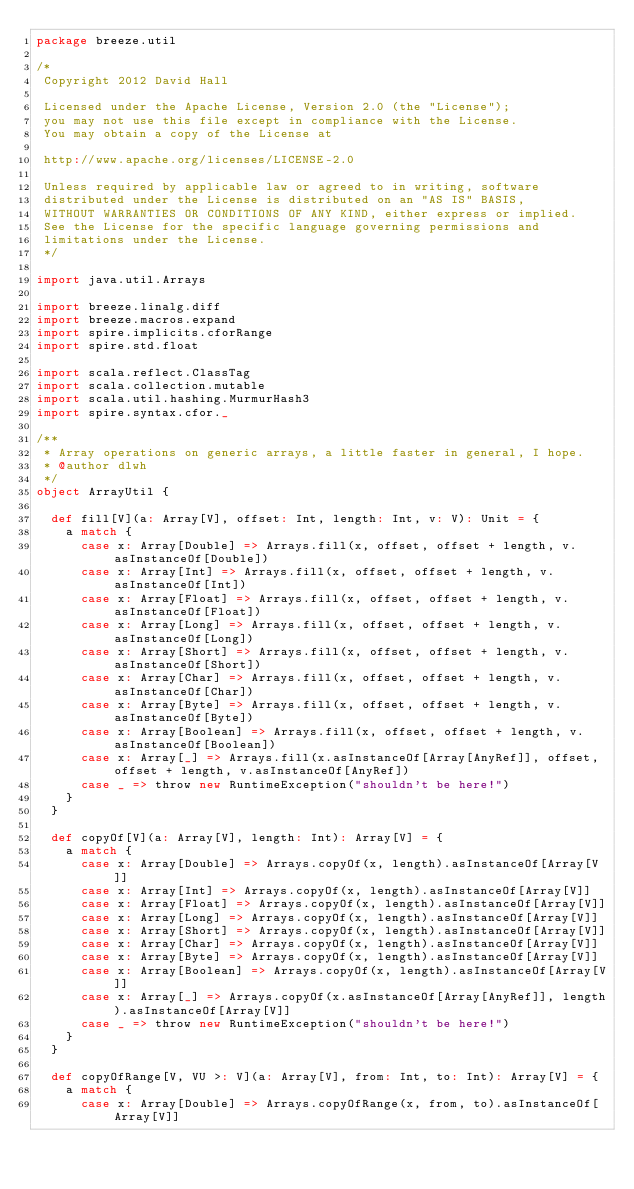<code> <loc_0><loc_0><loc_500><loc_500><_Scala_>package breeze.util

/*
 Copyright 2012 David Hall

 Licensed under the Apache License, Version 2.0 (the "License");
 you may not use this file except in compliance with the License.
 You may obtain a copy of the License at

 http://www.apache.org/licenses/LICENSE-2.0

 Unless required by applicable law or agreed to in writing, software
 distributed under the License is distributed on an "AS IS" BASIS,
 WITHOUT WARRANTIES OR CONDITIONS OF ANY KIND, either express or implied.
 See the License for the specific language governing permissions and
 limitations under the License.
 */

import java.util.Arrays

import breeze.linalg.diff
import breeze.macros.expand
import spire.implicits.cforRange
import spire.std.float

import scala.reflect.ClassTag
import scala.collection.mutable
import scala.util.hashing.MurmurHash3
import spire.syntax.cfor._

/**
 * Array operations on generic arrays, a little faster in general, I hope.
 * @author dlwh
 */
object ArrayUtil {

  def fill[V](a: Array[V], offset: Int, length: Int, v: V): Unit = {
    a match {
      case x: Array[Double] => Arrays.fill(x, offset, offset + length, v.asInstanceOf[Double])
      case x: Array[Int] => Arrays.fill(x, offset, offset + length, v.asInstanceOf[Int])
      case x: Array[Float] => Arrays.fill(x, offset, offset + length, v.asInstanceOf[Float])
      case x: Array[Long] => Arrays.fill(x, offset, offset + length, v.asInstanceOf[Long])
      case x: Array[Short] => Arrays.fill(x, offset, offset + length, v.asInstanceOf[Short])
      case x: Array[Char] => Arrays.fill(x, offset, offset + length, v.asInstanceOf[Char])
      case x: Array[Byte] => Arrays.fill(x, offset, offset + length, v.asInstanceOf[Byte])
      case x: Array[Boolean] => Arrays.fill(x, offset, offset + length, v.asInstanceOf[Boolean])
      case x: Array[_] => Arrays.fill(x.asInstanceOf[Array[AnyRef]], offset, offset + length, v.asInstanceOf[AnyRef])
      case _ => throw new RuntimeException("shouldn't be here!")
    }
  }

  def copyOf[V](a: Array[V], length: Int): Array[V] = {
    a match {
      case x: Array[Double] => Arrays.copyOf(x, length).asInstanceOf[Array[V]]
      case x: Array[Int] => Arrays.copyOf(x, length).asInstanceOf[Array[V]]
      case x: Array[Float] => Arrays.copyOf(x, length).asInstanceOf[Array[V]]
      case x: Array[Long] => Arrays.copyOf(x, length).asInstanceOf[Array[V]]
      case x: Array[Short] => Arrays.copyOf(x, length).asInstanceOf[Array[V]]
      case x: Array[Char] => Arrays.copyOf(x, length).asInstanceOf[Array[V]]
      case x: Array[Byte] => Arrays.copyOf(x, length).asInstanceOf[Array[V]]
      case x: Array[Boolean] => Arrays.copyOf(x, length).asInstanceOf[Array[V]]
      case x: Array[_] => Arrays.copyOf(x.asInstanceOf[Array[AnyRef]], length).asInstanceOf[Array[V]]
      case _ => throw new RuntimeException("shouldn't be here!")
    }
  }

  def copyOfRange[V, VU >: V](a: Array[V], from: Int, to: Int): Array[V] = {
    a match {
      case x: Array[Double] => Arrays.copyOfRange(x, from, to).asInstanceOf[Array[V]]</code> 